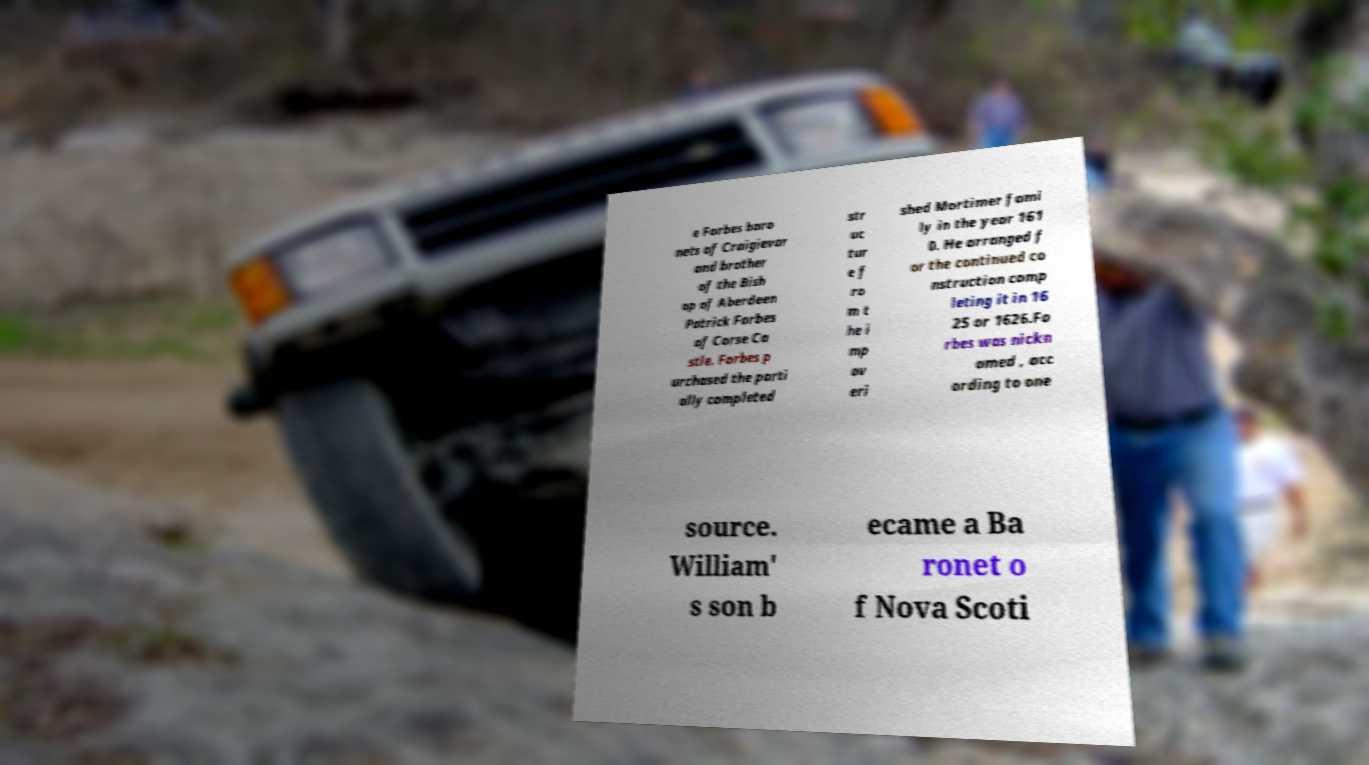Could you extract and type out the text from this image? e Forbes baro nets of Craigievar and brother of the Bish op of Aberdeen Patrick Forbes of Corse Ca stle. Forbes p urchased the parti ally completed str uc tur e f ro m t he i mp ov eri shed Mortimer fami ly in the year 161 0. He arranged f or the continued co nstruction comp leting it in 16 25 or 1626.Fo rbes was nickn amed , acc ording to one source. William' s son b ecame a Ba ronet o f Nova Scoti 